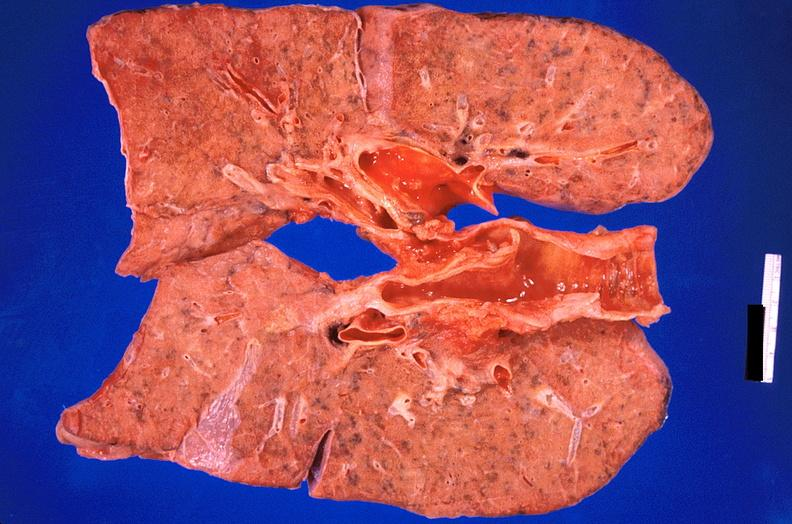what does this image show?
Answer the question using a single word or phrase. Lung 